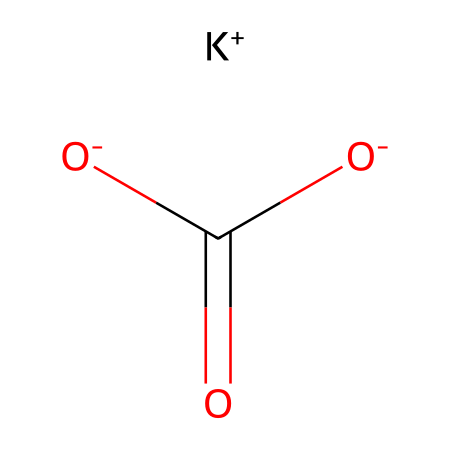What is the chemical's name? The chemical's SMILES notation indicates that it contains potassium (K) and bicarbonate (HCO3), which is commonly known as potassium bicarbonate.
Answer: potassium bicarbonate How many oxygen atoms are present? The SMILES notation shows the presence of two oxygen atoms in the molecule, as evidenced by the -O- and =O in the structure.
Answer: 2 What ionic forms are indicated in this structure? The presence of [K+] and [O-] in the SMILES indicates that there is a potassium ion and a negatively charged oxygen (in the bicarbonate) in the molecule.
Answer: potassium ion and acetate What is the charge of the potassium ion? The notation [K+] indicates a positive charge on the potassium ion, meaning it has lost one electron.
Answer: positive Why is potassium bicarbonate used in antacids? Potassium bicarbonate acts as a buffer that neutralizes stomach acid, providing relief from heartburn and indigestion, due to its bicarbonate ion which neutralizes acids.
Answer: neutralizes stomach acid How can potassium bicarbonate affect pH levels? As a bicarbonate salt, potassium bicarbonate can raise pH when dissolved in water, making the solution less acidic, as it reacts with hydrogen ions (H+) in the solution.
Answer: raises pH What role does the bicarbonate play in this compound? The bicarbonate ion (HCO3-) helps in neutralizing acids by reacting with them, thus reducing acidity, crucial for the function of antacids.
Answer: neutralizes acids 